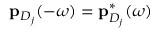<formula> <loc_0><loc_0><loc_500><loc_500>p _ { D _ { j } } ( - \omega ) = p _ { D _ { j } } ^ { * } ( \omega )</formula> 